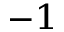Convert formula to latex. <formula><loc_0><loc_0><loc_500><loc_500>^ { - 1 }</formula> 